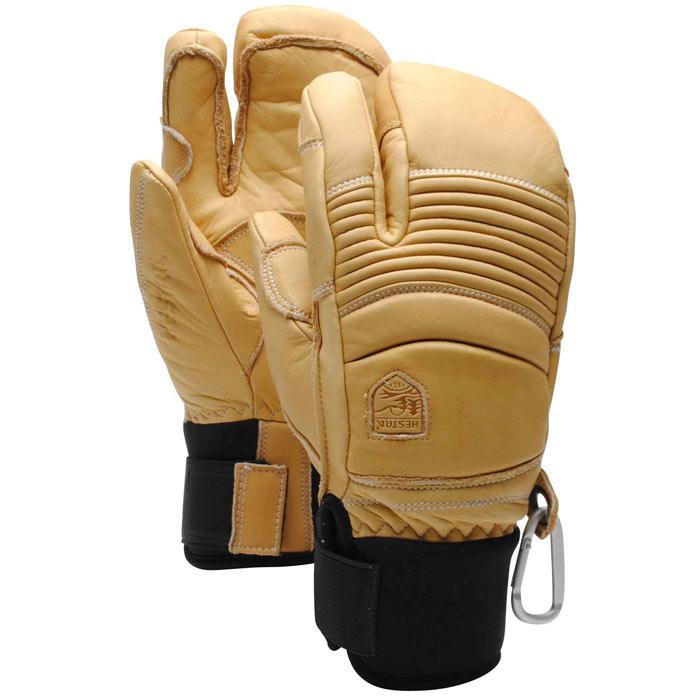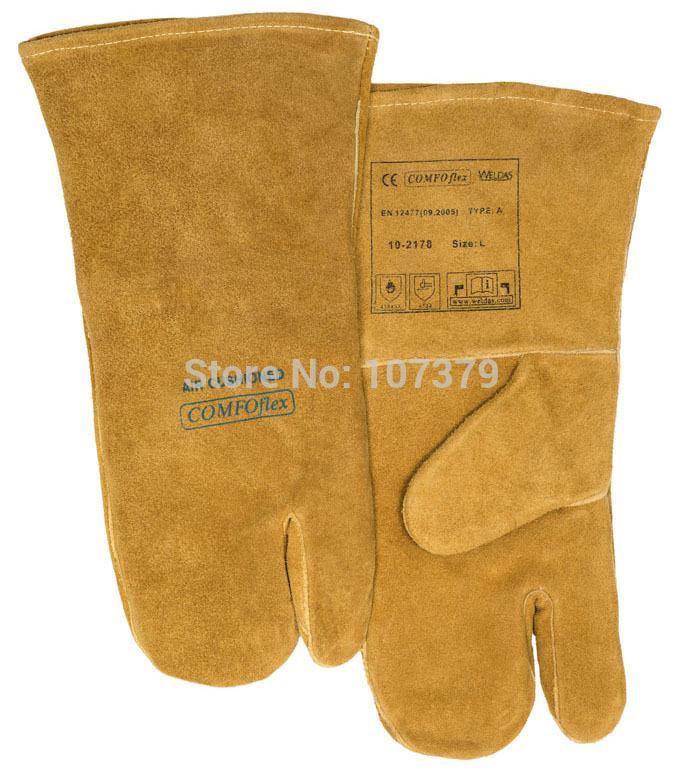The first image is the image on the left, the second image is the image on the right. Evaluate the accuracy of this statement regarding the images: "Both images show the front and back side of a pair of gloves.". Is it true? Answer yes or no. Yes. The first image is the image on the left, the second image is the image on the right. Assess this claim about the two images: "Each image contains one complete pair of mittens designed with one finger separated from the rest.". Correct or not? Answer yes or no. Yes. 